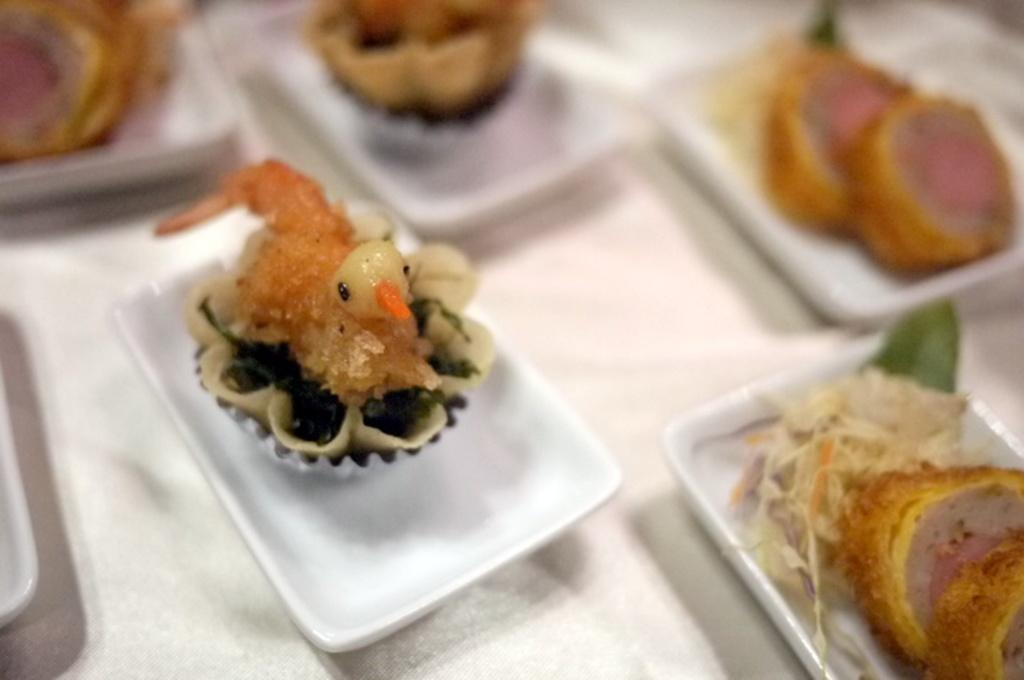What type of food can be seen in the image? There are snacks in the image. How are the snacks arranged or presented? The snacks are in a white plate. Where is the white plate with snacks located? The white plate with snacks is placed on a table top. What type of cherry can be seen growing on the table in the image? There is no cherry plant or fruit present in the image. What type of trains can be seen passing by in the image? There is no train visible in the image. 